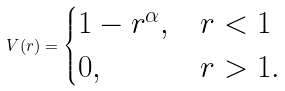<formula> <loc_0><loc_0><loc_500><loc_500>V ( r ) = \begin{cases} 1 - r ^ { \alpha } , & r < 1 \\ 0 , & r > 1 . \end{cases}</formula> 